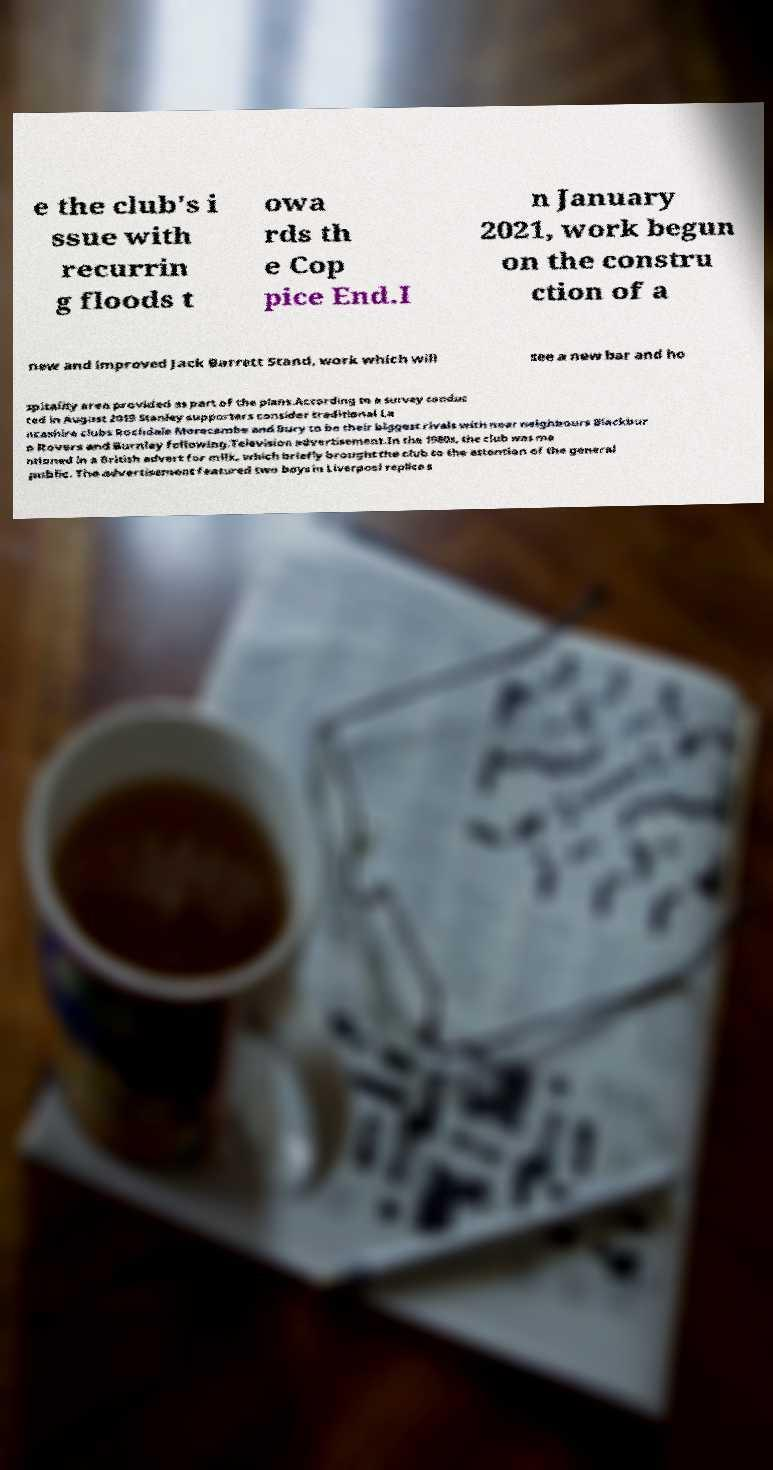Can you accurately transcribe the text from the provided image for me? e the club's i ssue with recurrin g floods t owa rds th e Cop pice End.I n January 2021, work begun on the constru ction of a new and improved Jack Barrett Stand, work which will see a new bar and ho spitality area provided as part of the plans.According to a survey conduc ted in August 2019 Stanley supporters consider traditional La ncashire clubs Rochdale Morecambe and Bury to be their biggest rivals with near neighbours Blackbur n Rovers and Burnley following.Television advertisement.In the 1980s, the club was me ntioned in a British advert for milk, which briefly brought the club to the attention of the general public. The advertisement featured two boys in Liverpool replica s 